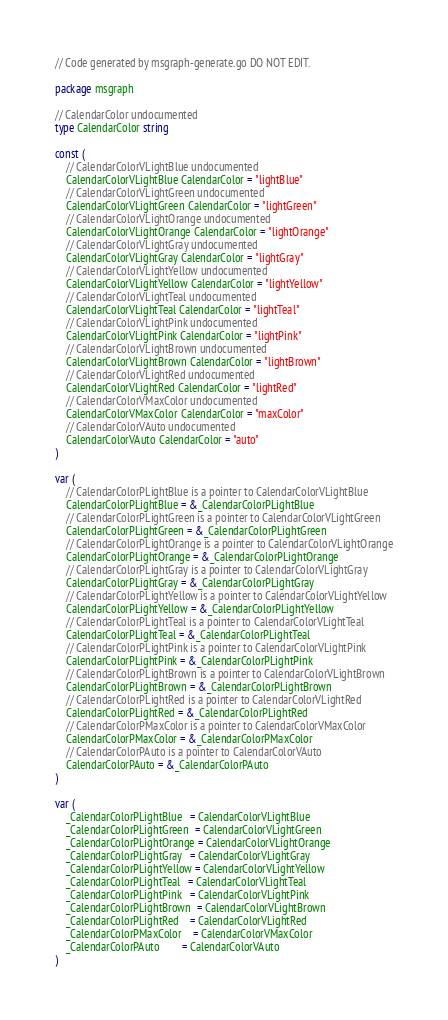<code> <loc_0><loc_0><loc_500><loc_500><_Go_>// Code generated by msgraph-generate.go DO NOT EDIT.

package msgraph

// CalendarColor undocumented
type CalendarColor string

const (
	// CalendarColorVLightBlue undocumented
	CalendarColorVLightBlue CalendarColor = "lightBlue"
	// CalendarColorVLightGreen undocumented
	CalendarColorVLightGreen CalendarColor = "lightGreen"
	// CalendarColorVLightOrange undocumented
	CalendarColorVLightOrange CalendarColor = "lightOrange"
	// CalendarColorVLightGray undocumented
	CalendarColorVLightGray CalendarColor = "lightGray"
	// CalendarColorVLightYellow undocumented
	CalendarColorVLightYellow CalendarColor = "lightYellow"
	// CalendarColorVLightTeal undocumented
	CalendarColorVLightTeal CalendarColor = "lightTeal"
	// CalendarColorVLightPink undocumented
	CalendarColorVLightPink CalendarColor = "lightPink"
	// CalendarColorVLightBrown undocumented
	CalendarColorVLightBrown CalendarColor = "lightBrown"
	// CalendarColorVLightRed undocumented
	CalendarColorVLightRed CalendarColor = "lightRed"
	// CalendarColorVMaxColor undocumented
	CalendarColorVMaxColor CalendarColor = "maxColor"
	// CalendarColorVAuto undocumented
	CalendarColorVAuto CalendarColor = "auto"
)

var (
	// CalendarColorPLightBlue is a pointer to CalendarColorVLightBlue
	CalendarColorPLightBlue = &_CalendarColorPLightBlue
	// CalendarColorPLightGreen is a pointer to CalendarColorVLightGreen
	CalendarColorPLightGreen = &_CalendarColorPLightGreen
	// CalendarColorPLightOrange is a pointer to CalendarColorVLightOrange
	CalendarColorPLightOrange = &_CalendarColorPLightOrange
	// CalendarColorPLightGray is a pointer to CalendarColorVLightGray
	CalendarColorPLightGray = &_CalendarColorPLightGray
	// CalendarColorPLightYellow is a pointer to CalendarColorVLightYellow
	CalendarColorPLightYellow = &_CalendarColorPLightYellow
	// CalendarColorPLightTeal is a pointer to CalendarColorVLightTeal
	CalendarColorPLightTeal = &_CalendarColorPLightTeal
	// CalendarColorPLightPink is a pointer to CalendarColorVLightPink
	CalendarColorPLightPink = &_CalendarColorPLightPink
	// CalendarColorPLightBrown is a pointer to CalendarColorVLightBrown
	CalendarColorPLightBrown = &_CalendarColorPLightBrown
	// CalendarColorPLightRed is a pointer to CalendarColorVLightRed
	CalendarColorPLightRed = &_CalendarColorPLightRed
	// CalendarColorPMaxColor is a pointer to CalendarColorVMaxColor
	CalendarColorPMaxColor = &_CalendarColorPMaxColor
	// CalendarColorPAuto is a pointer to CalendarColorVAuto
	CalendarColorPAuto = &_CalendarColorPAuto
)

var (
	_CalendarColorPLightBlue   = CalendarColorVLightBlue
	_CalendarColorPLightGreen  = CalendarColorVLightGreen
	_CalendarColorPLightOrange = CalendarColorVLightOrange
	_CalendarColorPLightGray   = CalendarColorVLightGray
	_CalendarColorPLightYellow = CalendarColorVLightYellow
	_CalendarColorPLightTeal   = CalendarColorVLightTeal
	_CalendarColorPLightPink   = CalendarColorVLightPink
	_CalendarColorPLightBrown  = CalendarColorVLightBrown
	_CalendarColorPLightRed    = CalendarColorVLightRed
	_CalendarColorPMaxColor    = CalendarColorVMaxColor
	_CalendarColorPAuto        = CalendarColorVAuto
)
</code> 